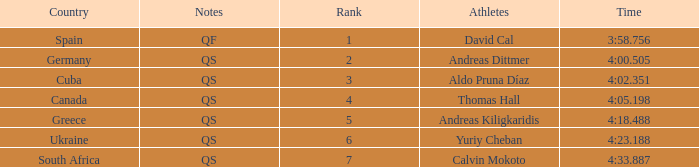What are the notes for the athlete from South Africa? QS. 